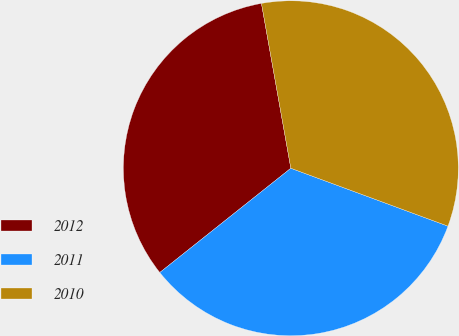Convert chart to OTSL. <chart><loc_0><loc_0><loc_500><loc_500><pie_chart><fcel>2012<fcel>2011<fcel>2010<nl><fcel>32.89%<fcel>33.69%<fcel>33.43%<nl></chart> 